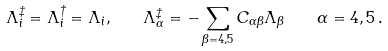<formula> <loc_0><loc_0><loc_500><loc_500>\Lambda _ { i } ^ { \ddagger } = \Lambda _ { i } ^ { \dagger } = \Lambda _ { i } , \quad \Lambda _ { \alpha } ^ { \ddagger } = - \sum _ { \beta = 4 , 5 } C _ { \alpha \beta } \Lambda _ { \beta } \, \quad \alpha = 4 , 5 \, .</formula> 